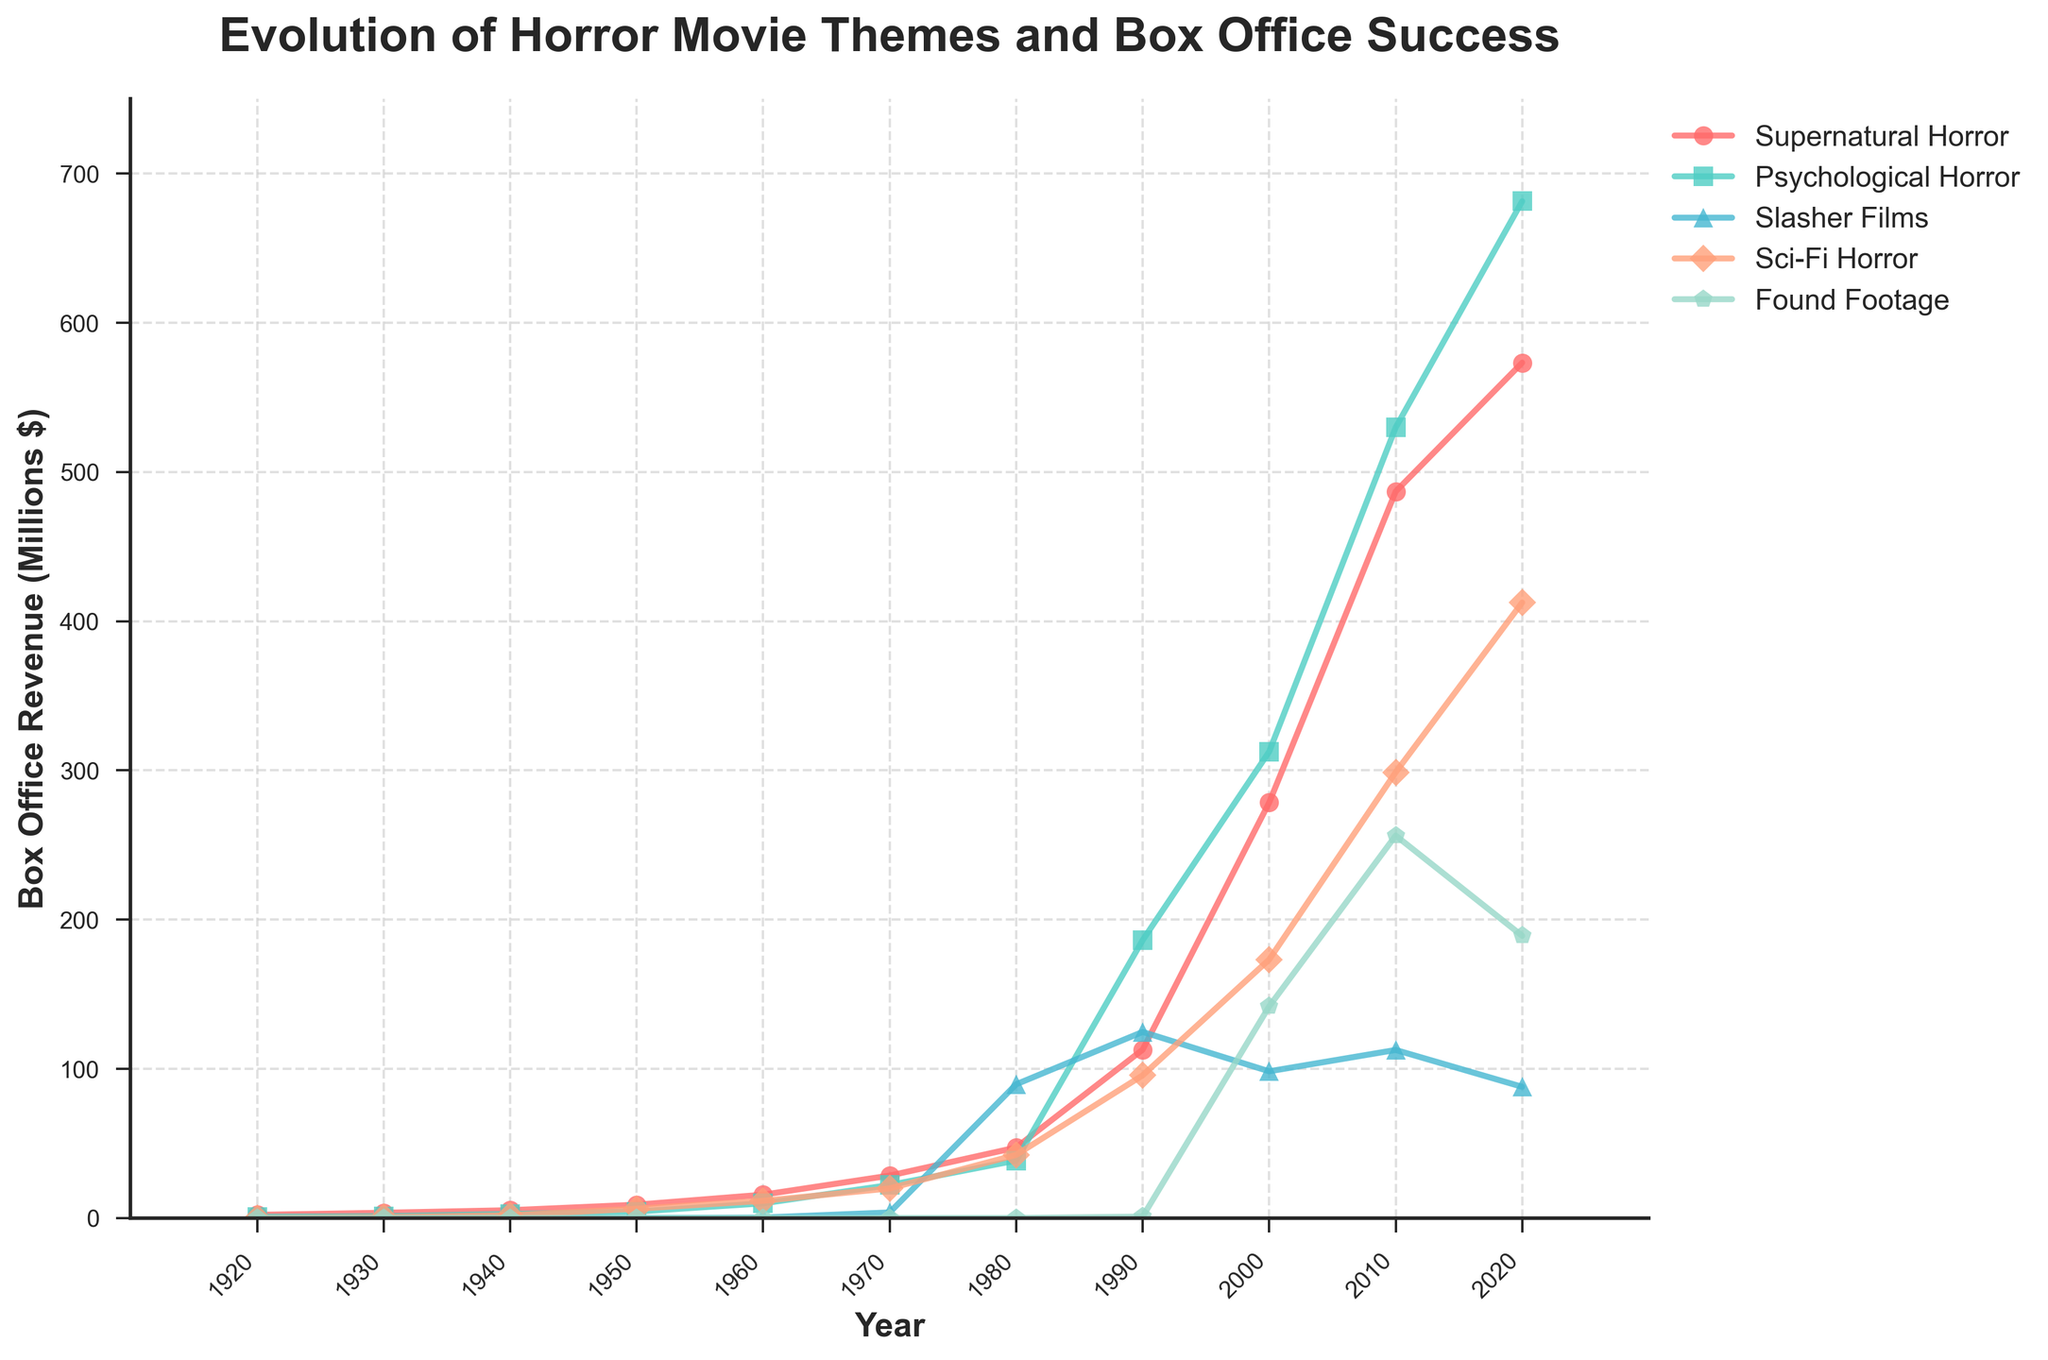What is the box office revenue for Supernatural Horror in 1980? The figure shows the box office revenue for Supernatural Horror by year. In 1980, the revenue for Supernatural Horror intersects the y-axis at approximately $47.2 million.
Answer: $47.2 million Among the five genres, which had the highest box office revenue in 2010? The figure indicates the box office revenue for each genre in 2010. Psychological Horror is the highest, with a revenue of $529.8 million.
Answer: Psychological Horror How much more revenue did Sci-Fi Horror generate in 2020 compared to 1950? In 2020, the box office revenue for Sci-Fi Horror is about $412.5 million, while in 1950, it is $6.2 million. The difference can be calculated as $412.5M - $6.2M = $406.3M.
Answer: $406.3 million Which genre showed the most significant increase in revenue between 1930 and 1980? By examining the figure, Supernatural Horror increased from about $3.5 million in 1930 to about $47.2 million in 1980, significantly more than the other genres.
Answer: Supernatural Horror What is the average box office revenue for Found Footage films between 2000 and 2020? The figure shows that Found Footage revenue in 2000 is $141.8 million, in 2010 is $256.3 million, and in 2020 is $189.1 million. The average is therefore (141.8 + 256.3 + 189.1)/3 = $195.73 million.
Answer: $195.73 million In which decade did Psychological Horror first surpass $100 million in box office revenue? The figure shows increments for Psychological Horror by decades. By 1980, it reached $186.2 million, which is the first instance it surpassed $100 million.
Answer: 1980s How does the box office revenue of Slasher Films in 2010 compare to that in 2000? The figure shows Slasher Films revenue as $112.6 million in 2010 and $98.3 million in 2000. Subtracting 98.3 from 112.6 gives us a difference of $14.3 million.
Answer: $14.3 million Which genre had the least box office revenue in 1920? The figure shows that Psychological Horror had a revenue of $0.8 million in 1920, while the other genres had either $2.1 million or zero. Therefore, it was the least.
Answer: Psychological Horror If you sum the box office revenues for Supernatural Horror and Psychological Horror in 1990, what is the total? The figure shows the revenue for Supernatural Horror in 1990 is $112.8 million and for Psychological Horror is $186.2 million. Summing these gives $112.8M + $186.2M = $299 million.
Answer: $299 million Which genre exhibited the fastest growth between 1990 and 2000? By examining the figure, Sci-Fi Horror’s revenue increased more rapidly than others, from $95.6 million to $173.2 million, which is a significant increment.
Answer: Sci-Fi Horror 